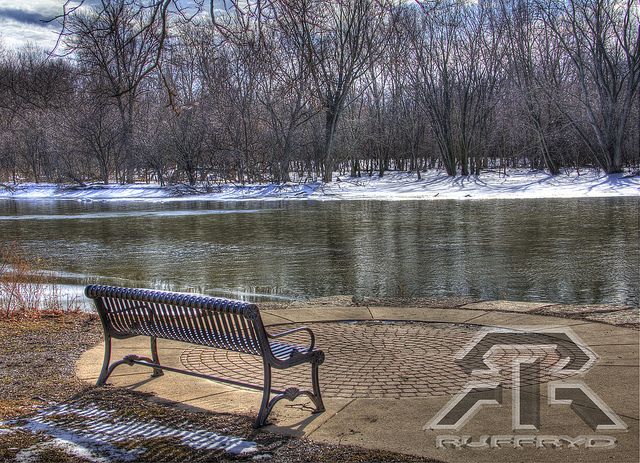Please extract the text content from this image. RUFFRYD 